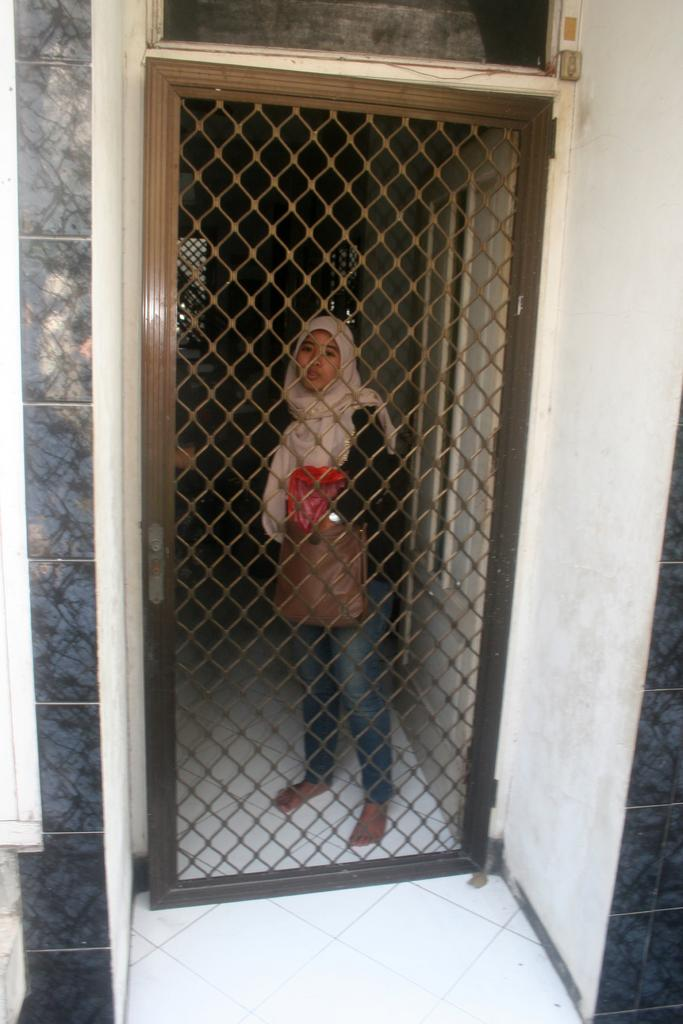What is the main subject of the image? There is a woman standing in the image. What is the woman standing on? The woman is standing on the floor. Can you describe any architectural features in the image? Yes, there is a mesh door in the image. What can be seen in the background of the image? There are windows visible in the background of the image. What type of dress is the woman wearing, and how does it smell of toothpaste in the image? There is no mention of a dress or toothpaste in the image, so we cannot determine what type of dress the woman is wearing or if it smells of toothpaste. 